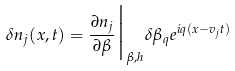Convert formula to latex. <formula><loc_0><loc_0><loc_500><loc_500>\delta n _ { j } ( x , t ) = \frac { \partial n _ { j } } { \partial \beta } \Big | _ { \beta , h } \delta \beta _ { q } e ^ { i q ( x - v _ { j } t ) }</formula> 